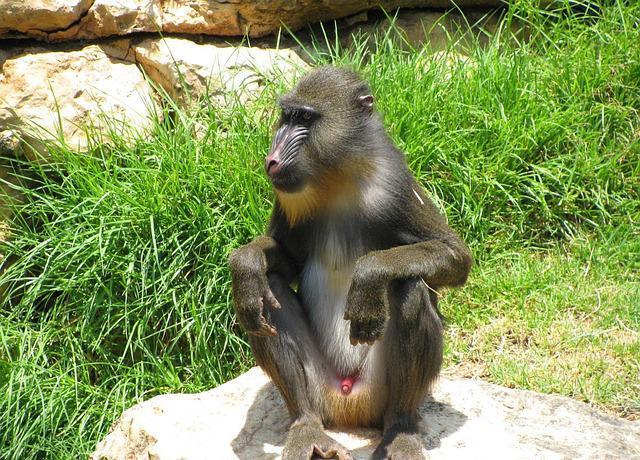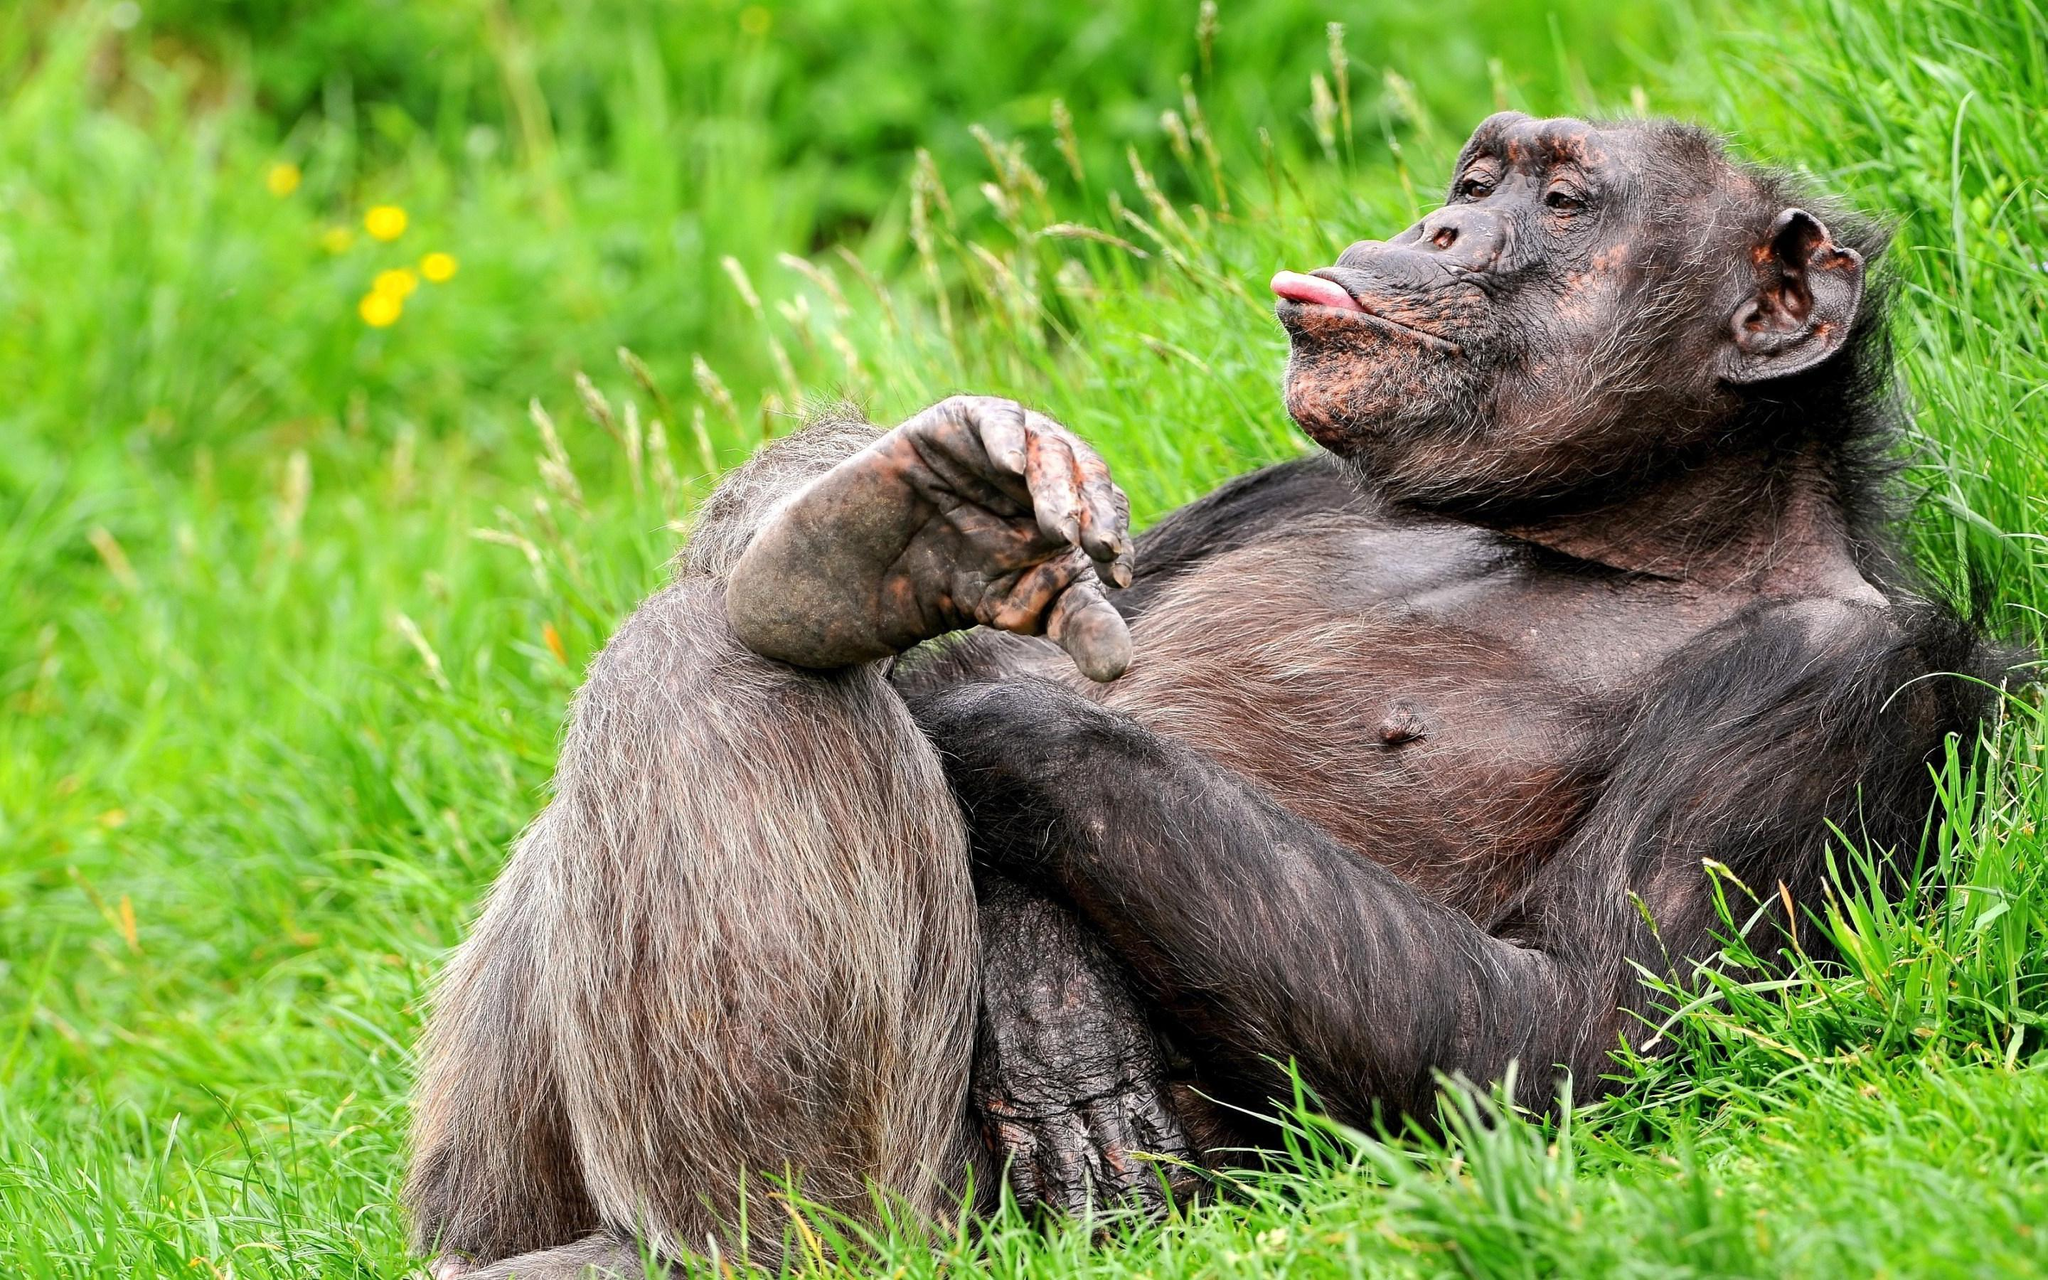The first image is the image on the left, the second image is the image on the right. Examine the images to the left and right. Is the description "There are three apes in total." accurate? Answer yes or no. No. 